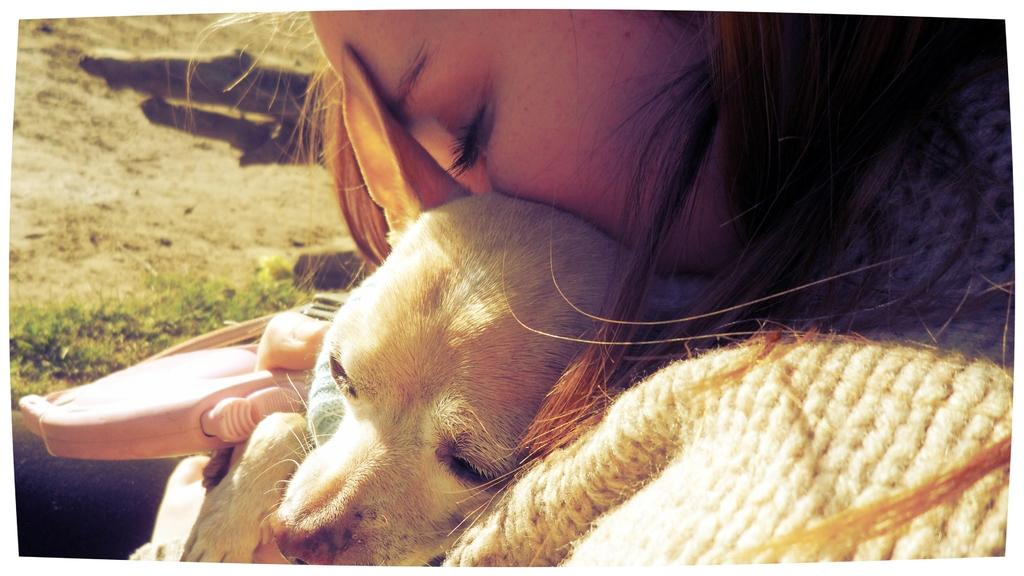Who is present in the image? There is a woman in the image. What other living creature can be seen in the image? There is a dog in the image. What type of knot is the woman tying around the dog's neck in the image? There is no knot present in the image, nor is the woman tying anything around the dog's neck. 